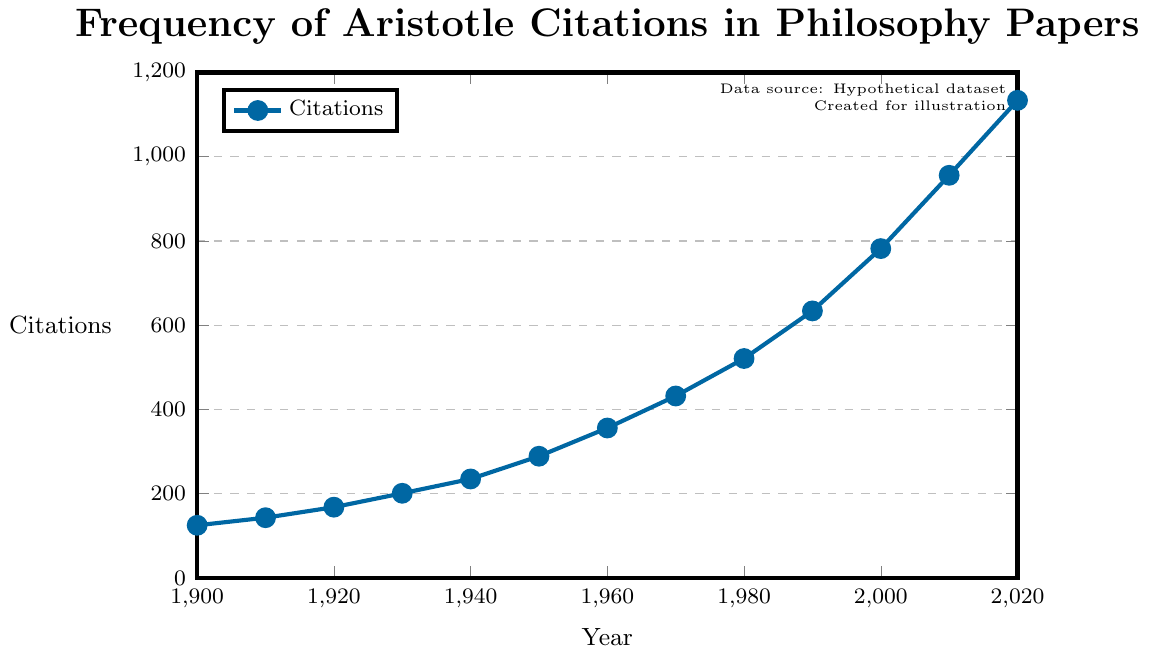What is the trend in the frequency of citations of Aristotle's works from 1900 to 2020? The trend is upward, with the frequency of citations increasing from 125 in 1900 to 1134 in 2020. The plot shows a steady rise in citations over the years.
Answer: Increasing How many citations of Aristotle's works were there in the year 1950? Refer to the data point corresponding to the year 1950 on the x-axis. The y-axis value at that point is 289.
Answer: 289 Which year experienced the highest number of citations of Aristotle's works? The highest point on the y-axis corresponds to the year 2020, where the value reaches 1134 citations.
Answer: 2020 How does the number of citations in 1910 compare to those in 1960? In 1910, the number of citations was 143, and in 1960, it was 356. Comparing these values, 1960 had significantly more citations than 1910.
Answer: 1960 had more What is the difference in the number of citations between 2000 and 2020? The number of citations in 2000 was 782, and in 2020 it was 1134. Subtract 782 from 1134 to find the difference: 1134 - 782 = 352.
Answer: 352 What is the average number of citations per decade from 1900 to 2020? There are 13 decades from 1900 to 2020. Sum the citations for each decade and divide by 13. (125 + 143 + 168 + 201 + 235 + 289 + 356 + 432 + 521 + 634 + 782 + 956 + 1134) = 6876. The average is 6876 / 13 ≈ 529
Answer: 529 In what year did Aristotle's works first receive more than 500 citations per year? Locate the data point where the y-axis value first exceeds 500. This occurs in the year 1980, where the number of citations is 521.
Answer: 1980 What is the percentage increase in citations from 1940 to 1980? In 1940, citations were 235, and in 1980, they were 521. The percentage increase is calculated as ((521 - 235) / 235) * 100. This equals (286 / 235) * 100 ≈ 121.7%.
Answer: 121.7% What is the median number of citations over the entire period from 1900 to 2020? Arrange the citation numbers in ascending order and find the middle value. The citation numbers are: 125, 143, 168, 201, 235, 289, 356, 432, 521, 634, 782, 956, 1134. The median is the 7th value in this ordered list, which is 356.
Answer: 356 